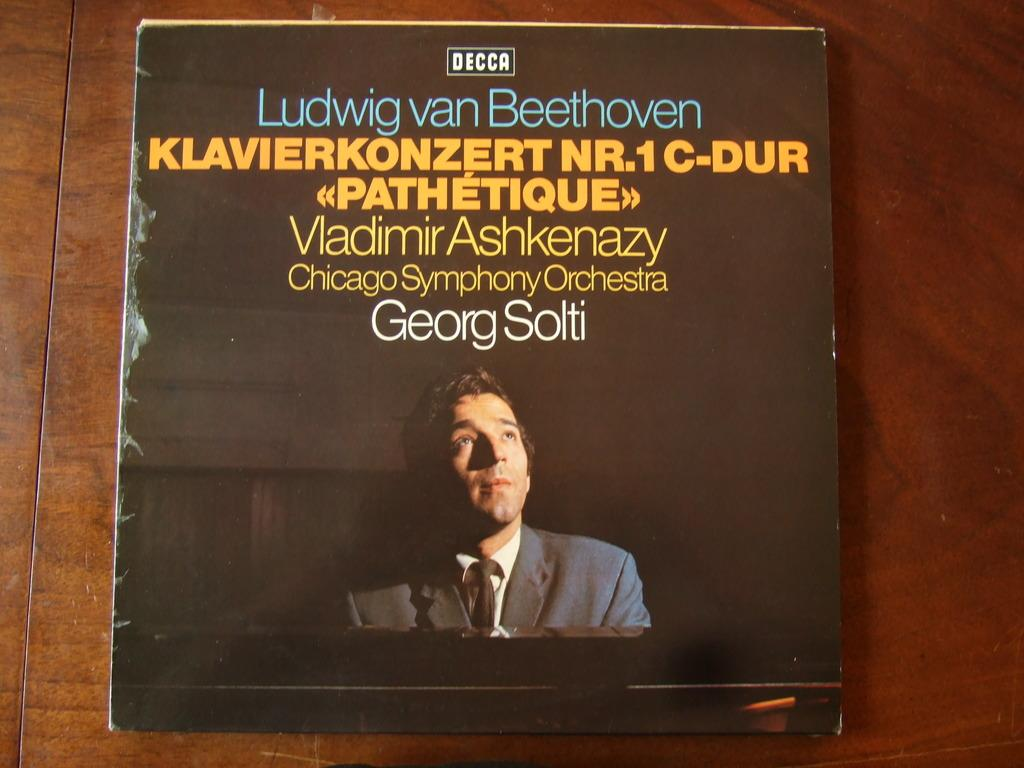What is the main subject of the image? The main subject of the image is a book cover. What can be seen on the book cover? There is a person's photo on the book cover. Are there any words on the book cover? Yes, there is text on the book cover. What type of beast can be seen on the book cover? There is no beast present on the book cover; it features a person's photo and text. What kind of pancake is being served on the book cover? There is no pancake present on the book cover; it is a book cover with a person's photo and text. 